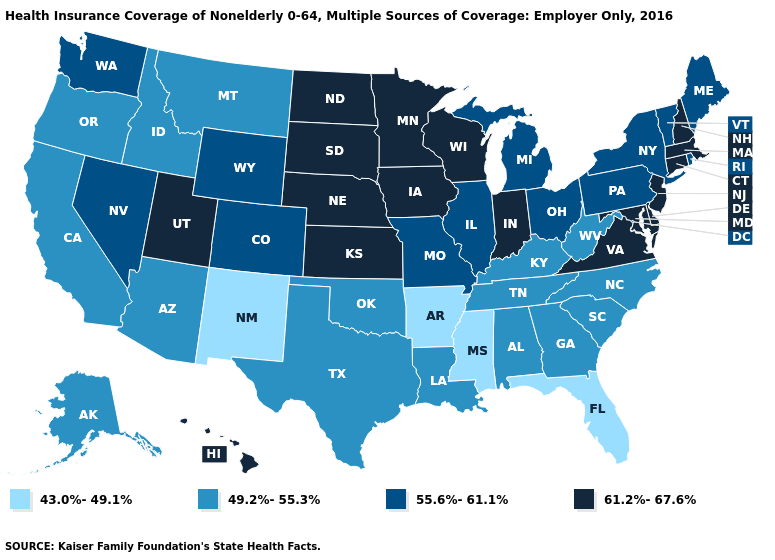Name the states that have a value in the range 43.0%-49.1%?
Give a very brief answer. Arkansas, Florida, Mississippi, New Mexico. What is the lowest value in the West?
Quick response, please. 43.0%-49.1%. What is the lowest value in the MidWest?
Be succinct. 55.6%-61.1%. What is the value of Ohio?
Write a very short answer. 55.6%-61.1%. Does Oklahoma have the same value as South Carolina?
Concise answer only. Yes. What is the value of Maryland?
Write a very short answer. 61.2%-67.6%. What is the value of West Virginia?
Write a very short answer. 49.2%-55.3%. Is the legend a continuous bar?
Be succinct. No. What is the value of Mississippi?
Concise answer only. 43.0%-49.1%. Name the states that have a value in the range 55.6%-61.1%?
Write a very short answer. Colorado, Illinois, Maine, Michigan, Missouri, Nevada, New York, Ohio, Pennsylvania, Rhode Island, Vermont, Washington, Wyoming. What is the lowest value in the MidWest?
Short answer required. 55.6%-61.1%. Among the states that border Colorado , does Nebraska have the highest value?
Keep it brief. Yes. Which states hav the highest value in the West?
Give a very brief answer. Hawaii, Utah. Does Kentucky have the highest value in the USA?
Quick response, please. No. Does Arizona have the same value as New York?
Quick response, please. No. 